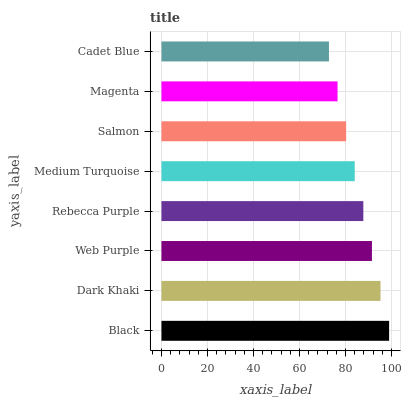Is Cadet Blue the minimum?
Answer yes or no. Yes. Is Black the maximum?
Answer yes or no. Yes. Is Dark Khaki the minimum?
Answer yes or no. No. Is Dark Khaki the maximum?
Answer yes or no. No. Is Black greater than Dark Khaki?
Answer yes or no. Yes. Is Dark Khaki less than Black?
Answer yes or no. Yes. Is Dark Khaki greater than Black?
Answer yes or no. No. Is Black less than Dark Khaki?
Answer yes or no. No. Is Rebecca Purple the high median?
Answer yes or no. Yes. Is Medium Turquoise the low median?
Answer yes or no. Yes. Is Cadet Blue the high median?
Answer yes or no. No. Is Magenta the low median?
Answer yes or no. No. 